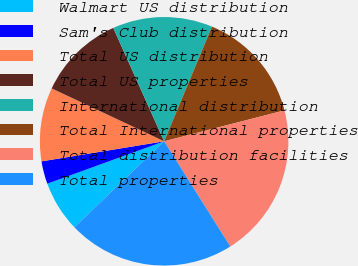<chart> <loc_0><loc_0><loc_500><loc_500><pie_chart><fcel>Walmart US distribution<fcel>Sam's Club distribution<fcel>Total US distribution<fcel>Total US properties<fcel>International distribution<fcel>Total International properties<fcel>Total distribution facilities<fcel>Total properties<nl><fcel>6.61%<fcel>2.96%<fcel>9.58%<fcel>11.29%<fcel>13.0%<fcel>14.71%<fcel>20.07%<fcel>21.78%<nl></chart> 